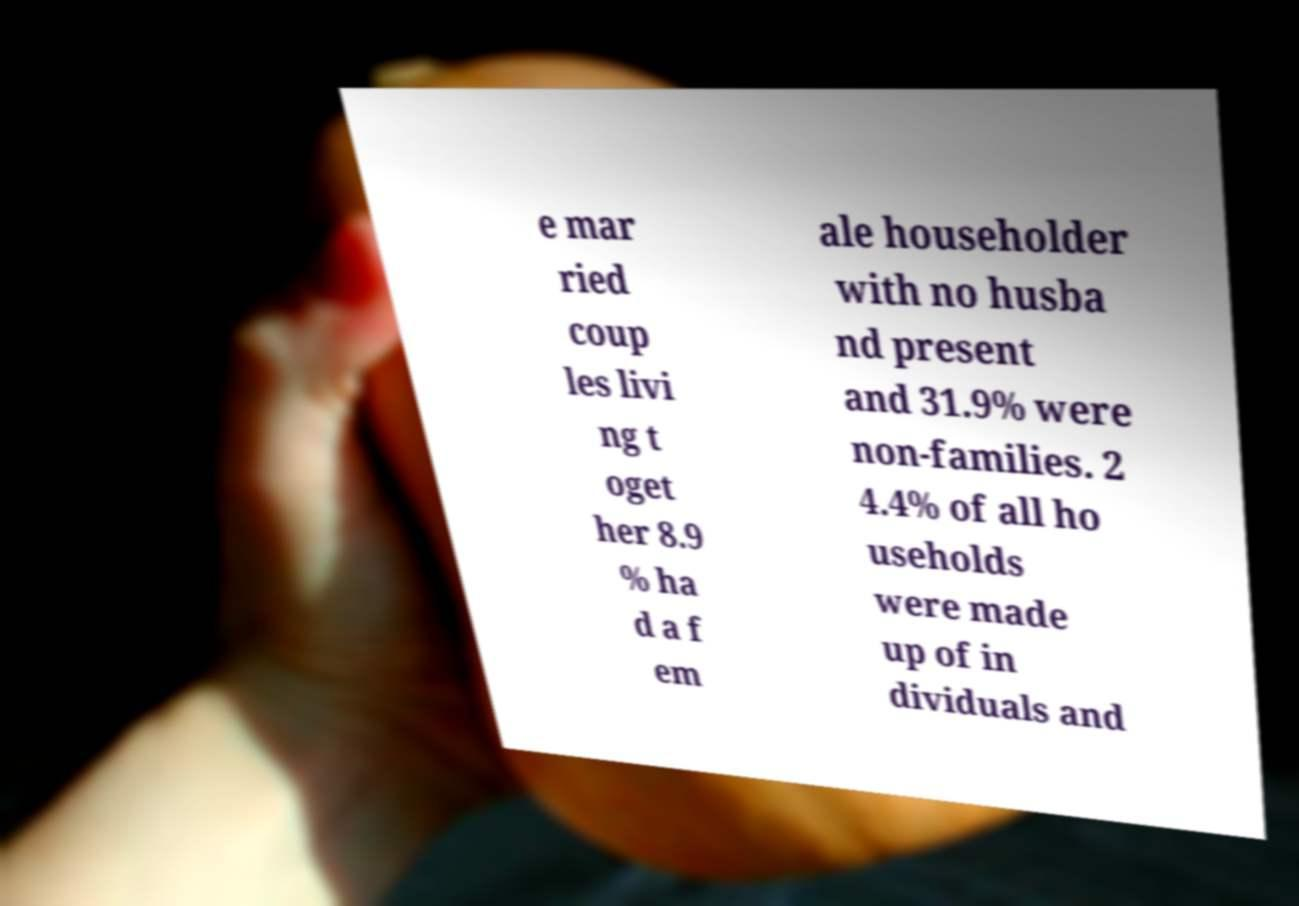There's text embedded in this image that I need extracted. Can you transcribe it verbatim? e mar ried coup les livi ng t oget her 8.9 % ha d a f em ale householder with no husba nd present and 31.9% were non-families. 2 4.4% of all ho useholds were made up of in dividuals and 